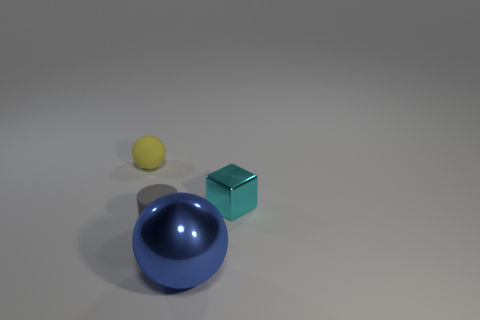There is a thing in front of the tiny gray cylinder; is its shape the same as the yellow rubber thing that is left of the cyan block?
Offer a very short reply. Yes. How big is the thing that is behind the small cylinder and to the right of the gray cylinder?
Offer a very short reply. Small. How many other things are there of the same color as the large sphere?
Offer a terse response. 0. Do the sphere in front of the small yellow thing and the cylinder have the same material?
Provide a short and direct response. No. Is there any other thing that has the same size as the metallic sphere?
Keep it short and to the point. No. Are there fewer things that are in front of the cyan object than blue things that are right of the blue object?
Give a very brief answer. No. Are there any other things that have the same shape as the small gray object?
Your answer should be compact. No. There is a tiny matte object that is behind the object on the right side of the blue thing; how many gray cylinders are right of it?
Your response must be concise. 1. There is a small gray cylinder; how many small gray rubber cylinders are in front of it?
Make the answer very short. 0. What number of big things are made of the same material as the tiny cyan cube?
Ensure brevity in your answer.  1. 